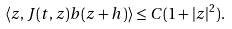Convert formula to latex. <formula><loc_0><loc_0><loc_500><loc_500>\langle z , J ( t , z ) b ( z + h ) \rangle \leq C ( 1 + | z | ^ { 2 } ) .</formula> 